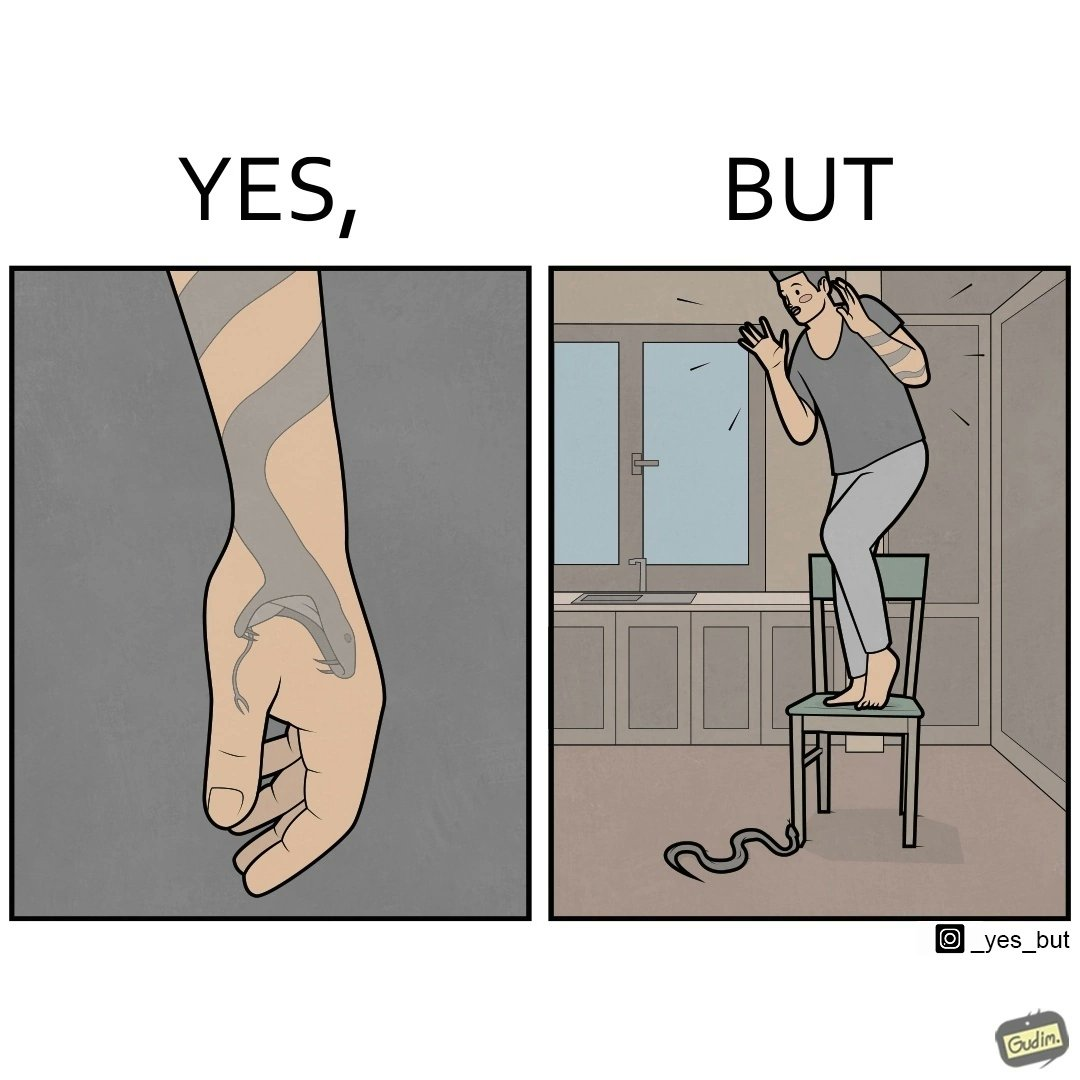Would you classify this image as satirical? Yes, this image is satirical. 